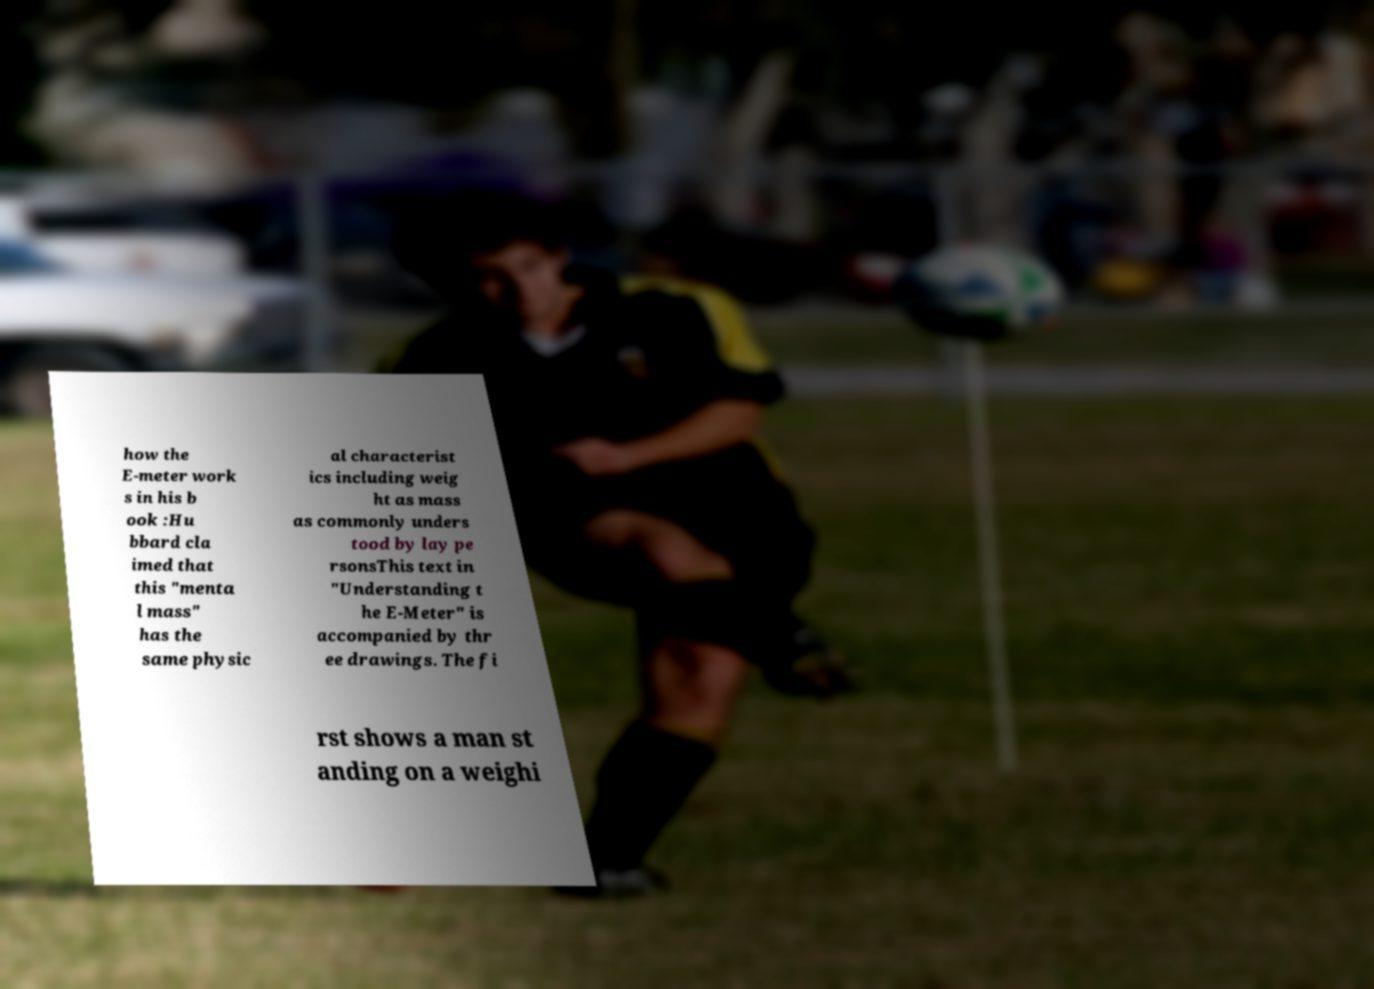Can you read and provide the text displayed in the image?This photo seems to have some interesting text. Can you extract and type it out for me? how the E-meter work s in his b ook :Hu bbard cla imed that this "menta l mass" has the same physic al characterist ics including weig ht as mass as commonly unders tood by lay pe rsonsThis text in "Understanding t he E-Meter" is accompanied by thr ee drawings. The fi rst shows a man st anding on a weighi 